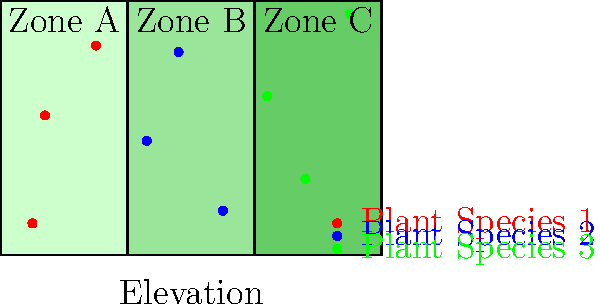Based on the ecological zone map provided, which plant species shows the most even distribution across all three zones, and what ecological factor might explain this distribution pattern? To answer this question, we need to analyze the distribution of each plant species across the three ecological zones:

1. Count the number of plants in each zone:
   - Plant Species 1 (red): 3 in Zone A, 0 in Zone B, 0 in Zone C
   - Plant Species 2 (blue): 0 in Zone A, 3 in Zone B, 0 in Zone C
   - Plant Species 3 (green): 0 in Zone A, 0 in Zone B, 3 in Zone C

2. Evaluate the evenness of distribution:
   - Plant Species 1 is concentrated in Zone A
   - Plant Species 2 is concentrated in Zone B
   - Plant Species 3 is concentrated in Zone C

3. Identify the most evenly distributed species:
   - None of the species are evenly distributed across all three zones

4. Consider ecological factors:
   - The zones are arranged along an elevation and distance gradient
   - Each species is restricted to a specific zone, suggesting specialized adaptations

5. Explain the distribution pattern:
   - The observed pattern indicates niche specialization
   - Each species has adapted to specific environmental conditions in its respective zone
   - These conditions may include soil type, moisture levels, temperature, or light availability

6. Conclude:
   - While no species shows an even distribution, this pattern reveals important ecological principles
   - The distribution suggests that environmental gradients play a crucial role in determining plant species distribution
Answer: No species shows even distribution; distribution pattern suggests niche specialization along environmental gradients. 